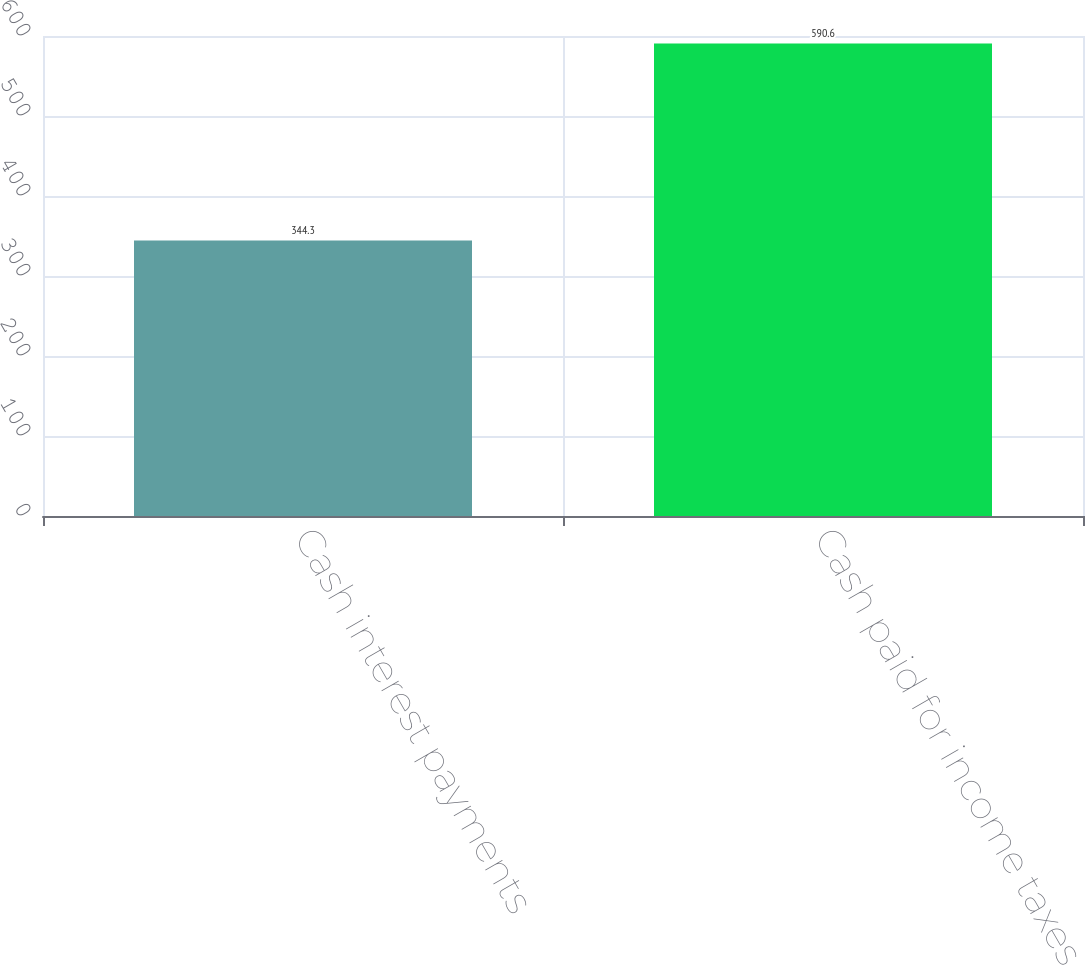Convert chart to OTSL. <chart><loc_0><loc_0><loc_500><loc_500><bar_chart><fcel>Cash interest payments<fcel>Cash paid for income taxes<nl><fcel>344.3<fcel>590.6<nl></chart> 